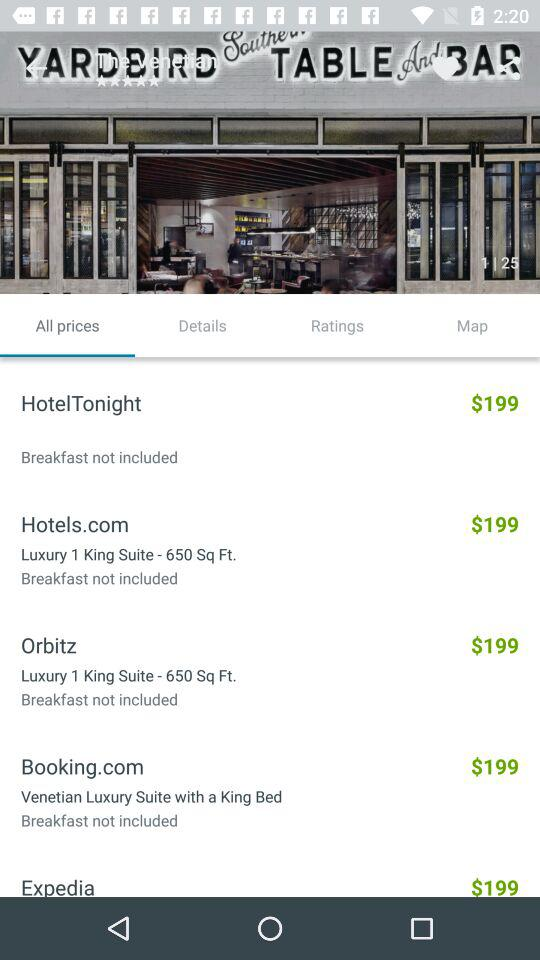How many hotels have a price of $199?
Answer the question using a single word or phrase. 5 